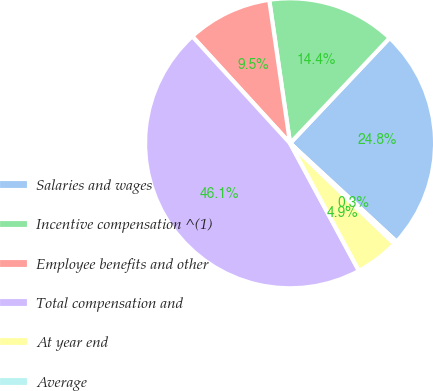<chart> <loc_0><loc_0><loc_500><loc_500><pie_chart><fcel>Salaries and wages<fcel>Incentive compensation ^(1)<fcel>Employee benefits and other<fcel>Total compensation and<fcel>At year end<fcel>Average<nl><fcel>24.82%<fcel>14.35%<fcel>9.49%<fcel>46.09%<fcel>4.91%<fcel>0.34%<nl></chart> 